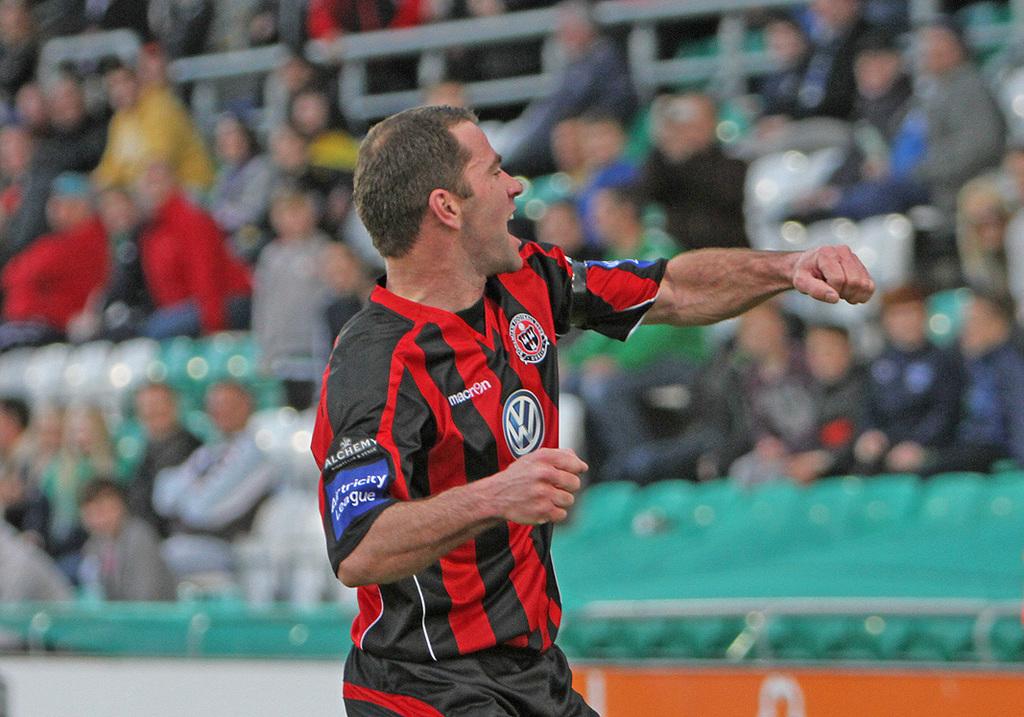What automotive brand sponsors this player?
Keep it short and to the point. Volkswagen. What is the name written on the chest?
Offer a terse response. Macron. 